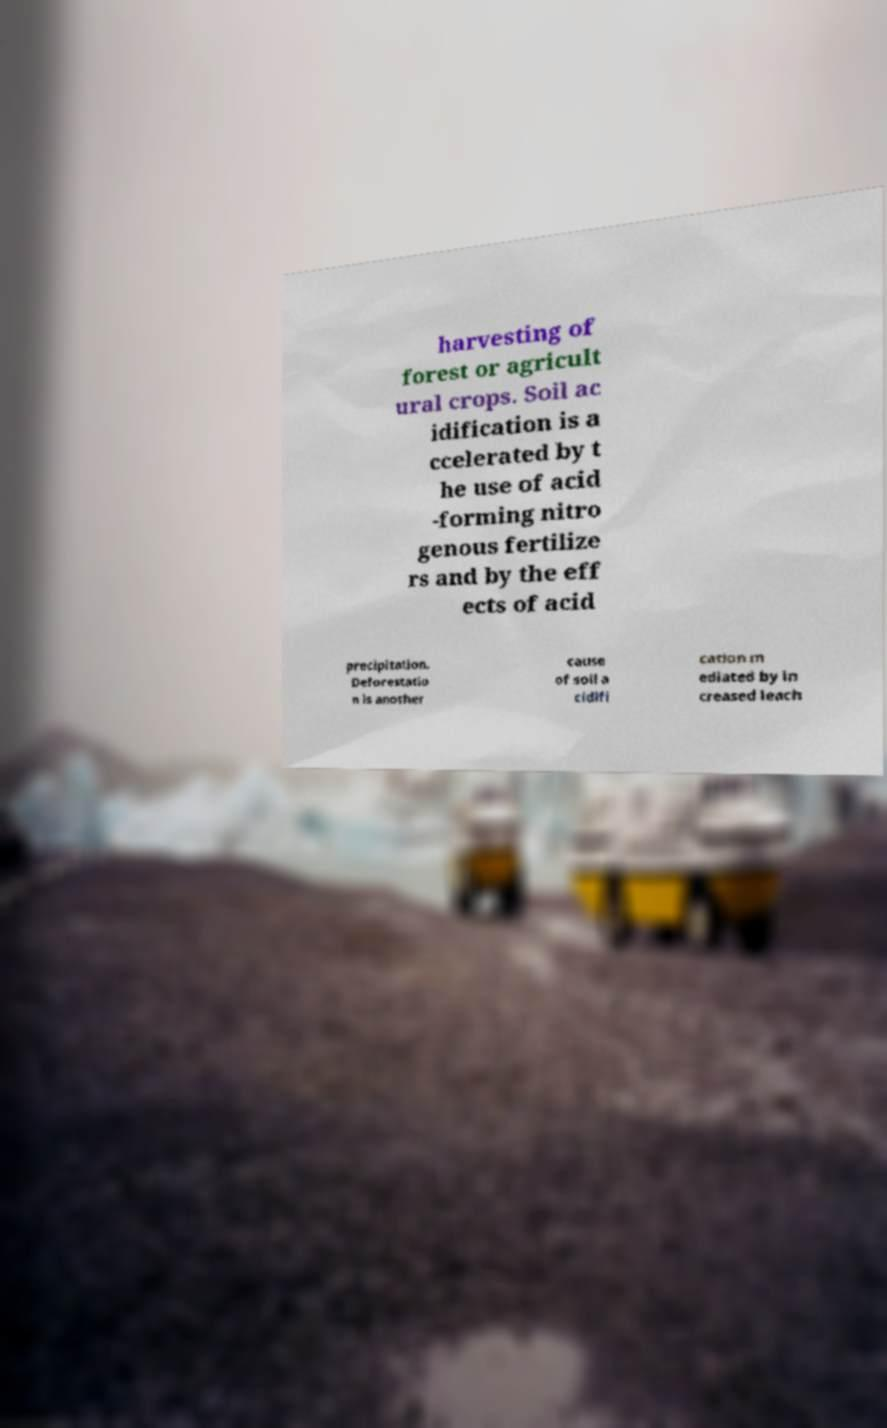Could you assist in decoding the text presented in this image and type it out clearly? harvesting of forest or agricult ural crops. Soil ac idification is a ccelerated by t he use of acid -forming nitro genous fertilize rs and by the eff ects of acid precipitation. Deforestatio n is another cause of soil a cidifi cation m ediated by in creased leach 